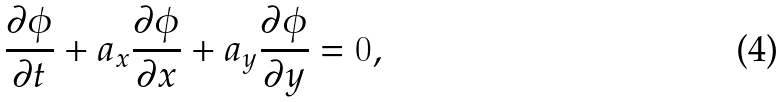Convert formula to latex. <formula><loc_0><loc_0><loc_500><loc_500>\frac { \partial \phi } { \partial t } + a _ { x } \frac { \partial \phi } { \partial x } + a _ { y } \frac { \partial \phi } { \partial y } = 0 ,</formula> 